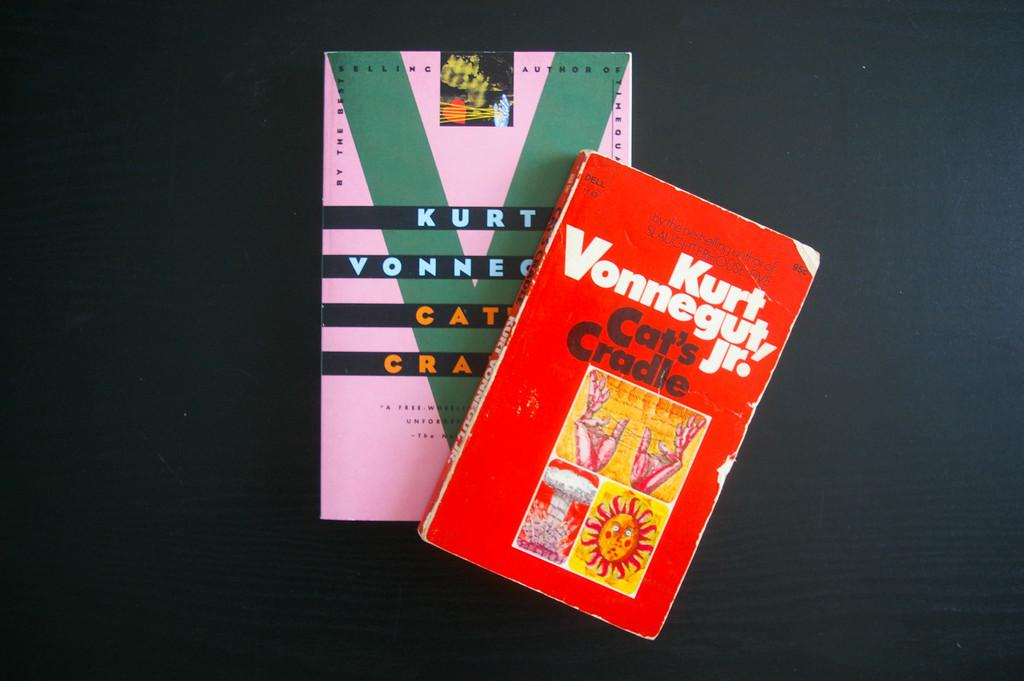<image>
Render a clear and concise summary of the photo. Two copies of Kurt Vonnegut's Cat's Cradle sit on top of one another. 